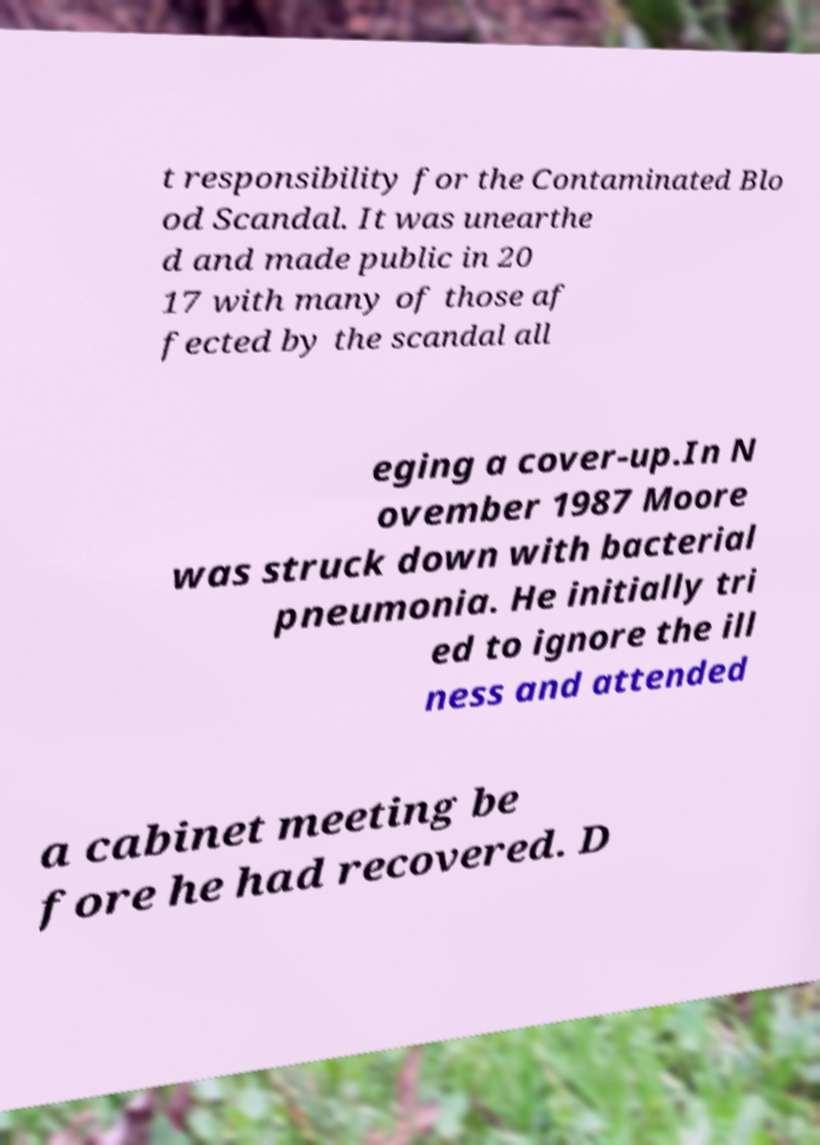Could you assist in decoding the text presented in this image and type it out clearly? t responsibility for the Contaminated Blo od Scandal. It was unearthe d and made public in 20 17 with many of those af fected by the scandal all eging a cover-up.In N ovember 1987 Moore was struck down with bacterial pneumonia. He initially tri ed to ignore the ill ness and attended a cabinet meeting be fore he had recovered. D 